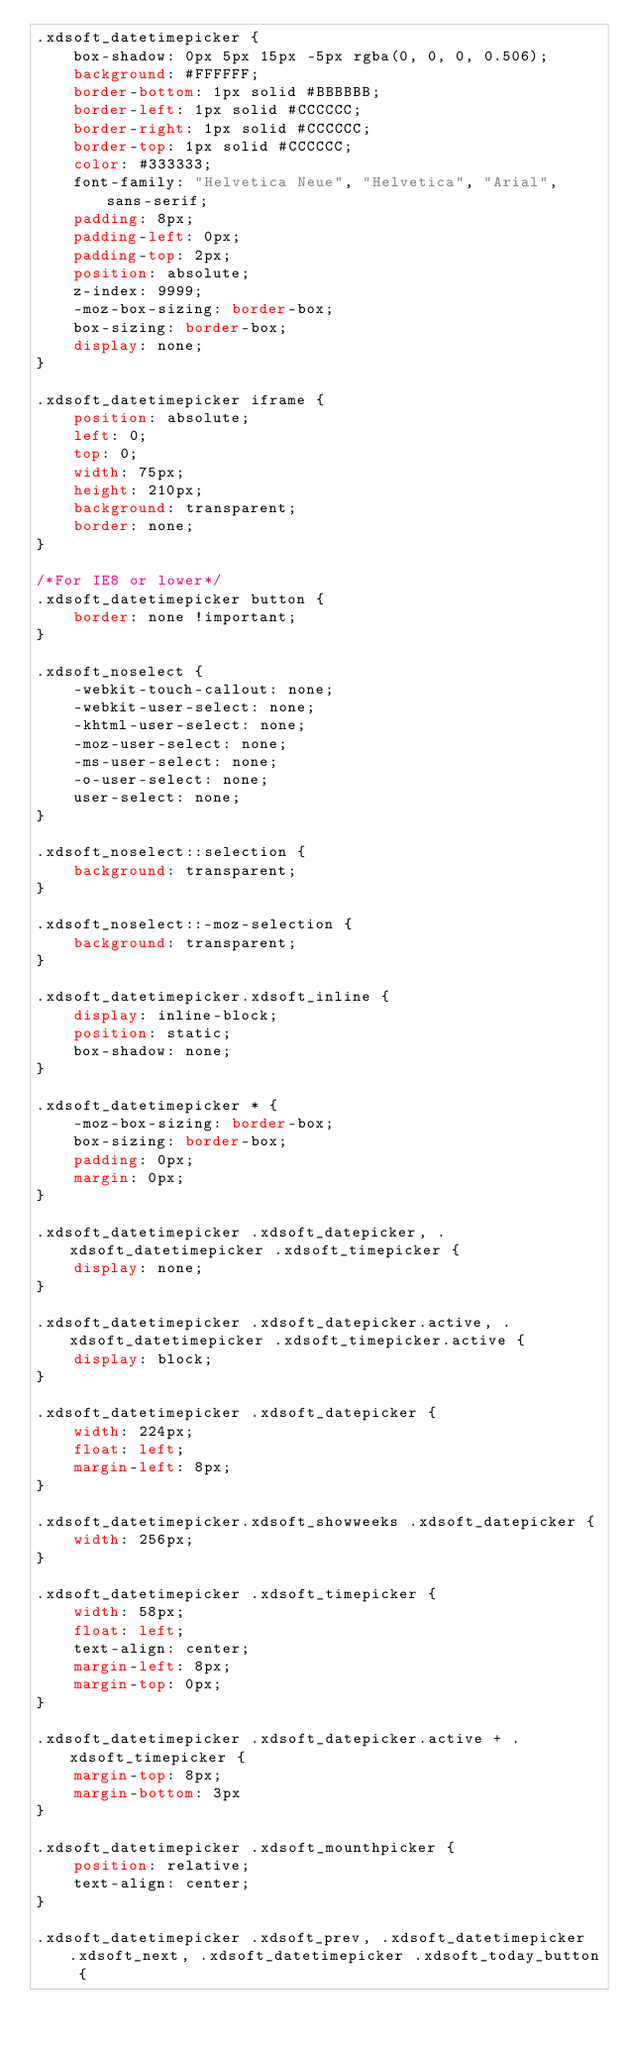Convert code to text. <code><loc_0><loc_0><loc_500><loc_500><_CSS_>.xdsoft_datetimepicker {
    box-shadow: 0px 5px 15px -5px rgba(0, 0, 0, 0.506);
    background: #FFFFFF;
    border-bottom: 1px solid #BBBBBB;
    border-left: 1px solid #CCCCCC;
    border-right: 1px solid #CCCCCC;
    border-top: 1px solid #CCCCCC;
    color: #333333;
    font-family: "Helvetica Neue", "Helvetica", "Arial", sans-serif;
    padding: 8px;
    padding-left: 0px;
    padding-top: 2px;
    position: absolute;
    z-index: 9999;
    -moz-box-sizing: border-box;
    box-sizing: border-box;
    display: none;
}

.xdsoft_datetimepicker iframe {
    position: absolute;
    left: 0;
    top: 0;
    width: 75px;
    height: 210px;
    background: transparent;
    border: none;
}

/*For IE8 or lower*/
.xdsoft_datetimepicker button {
    border: none !important;
}

.xdsoft_noselect {
    -webkit-touch-callout: none;
    -webkit-user-select: none;
    -khtml-user-select: none;
    -moz-user-select: none;
    -ms-user-select: none;
    -o-user-select: none;
    user-select: none;
}

.xdsoft_noselect::selection {
    background: transparent;
}

.xdsoft_noselect::-moz-selection {
    background: transparent;
}

.xdsoft_datetimepicker.xdsoft_inline {
    display: inline-block;
    position: static;
    box-shadow: none;
}

.xdsoft_datetimepicker * {
    -moz-box-sizing: border-box;
    box-sizing: border-box;
    padding: 0px;
    margin: 0px;
}

.xdsoft_datetimepicker .xdsoft_datepicker, .xdsoft_datetimepicker .xdsoft_timepicker {
    display: none;
}

.xdsoft_datetimepicker .xdsoft_datepicker.active, .xdsoft_datetimepicker .xdsoft_timepicker.active {
    display: block;
}

.xdsoft_datetimepicker .xdsoft_datepicker {
    width: 224px;
    float: left;
    margin-left: 8px;
}

.xdsoft_datetimepicker.xdsoft_showweeks .xdsoft_datepicker {
    width: 256px;
}

.xdsoft_datetimepicker .xdsoft_timepicker {
    width: 58px;
    float: left;
    text-align: center;
    margin-left: 8px;
    margin-top: 0px;
}

.xdsoft_datetimepicker .xdsoft_datepicker.active + .xdsoft_timepicker {
    margin-top: 8px;
    margin-bottom: 3px
}

.xdsoft_datetimepicker .xdsoft_mounthpicker {
    position: relative;
    text-align: center;
}

.xdsoft_datetimepicker .xdsoft_prev, .xdsoft_datetimepicker .xdsoft_next, .xdsoft_datetimepicker .xdsoft_today_button {</code> 